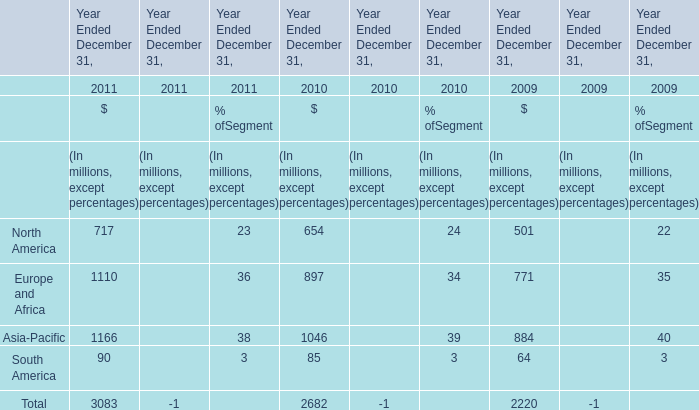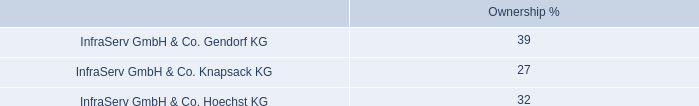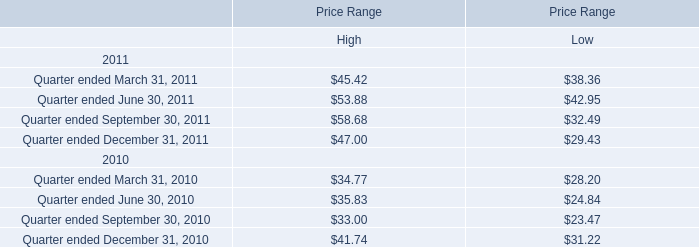What is the sum of the Europe and Africa in the years where North America is greater than 700 million? (in million) 
Answer: 1110. 